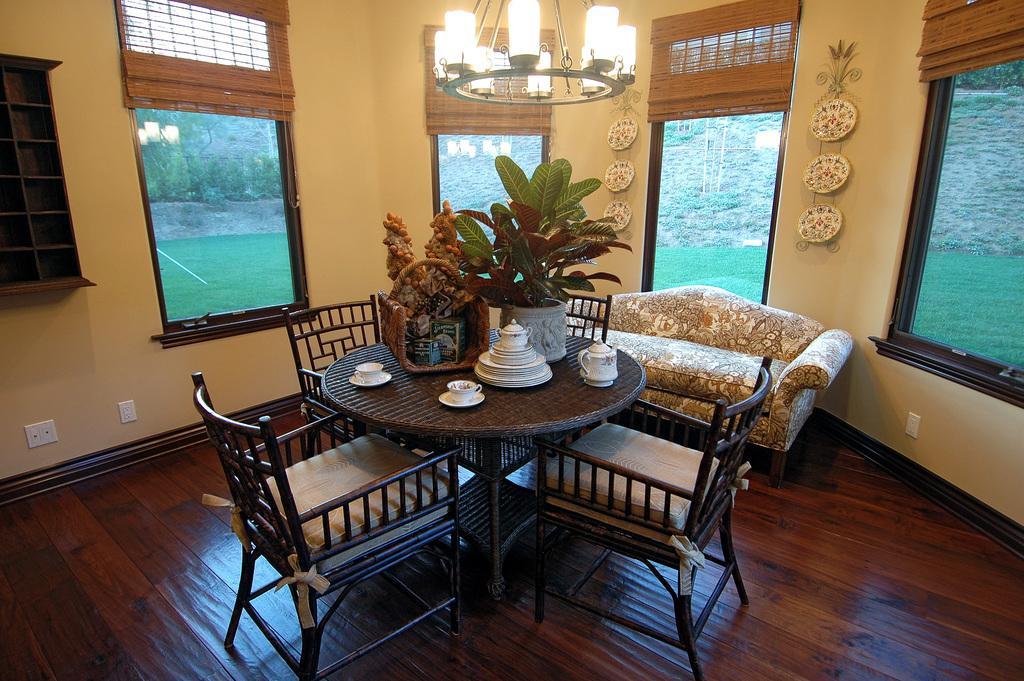Please provide a concise description of this image. here we can see the table and flower pot and tea cup and some objects on it, and here is the sofa on the floor ,and at back here is the wall, and at top here is the lights, and here is the window and there are trees. 